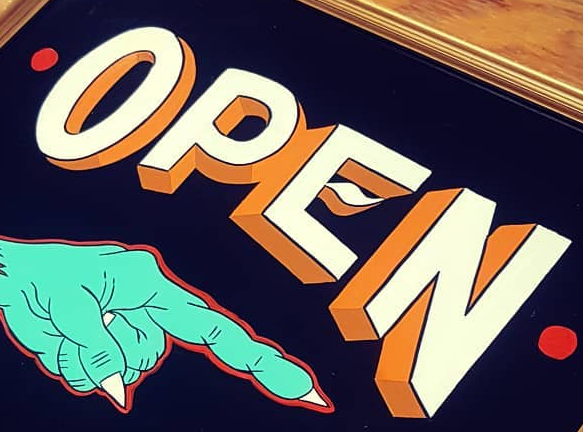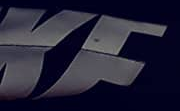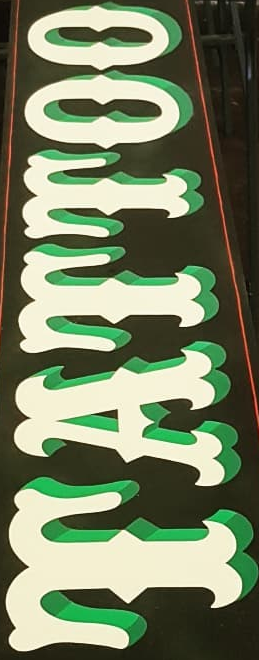Transcribe the words shown in these images in order, separated by a semicolon. OPEN; KF; TATTOO 